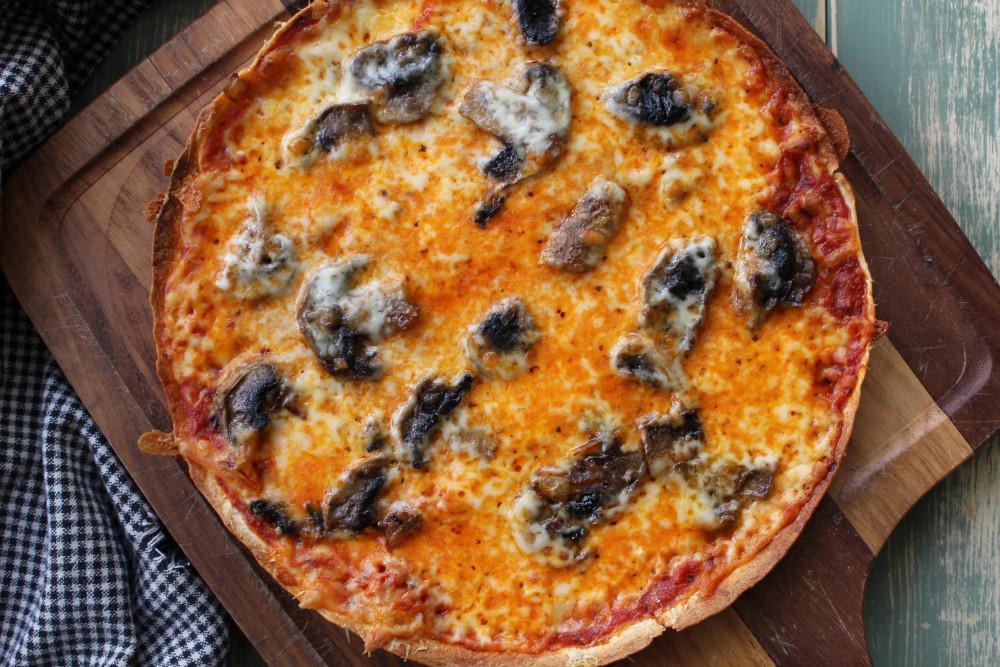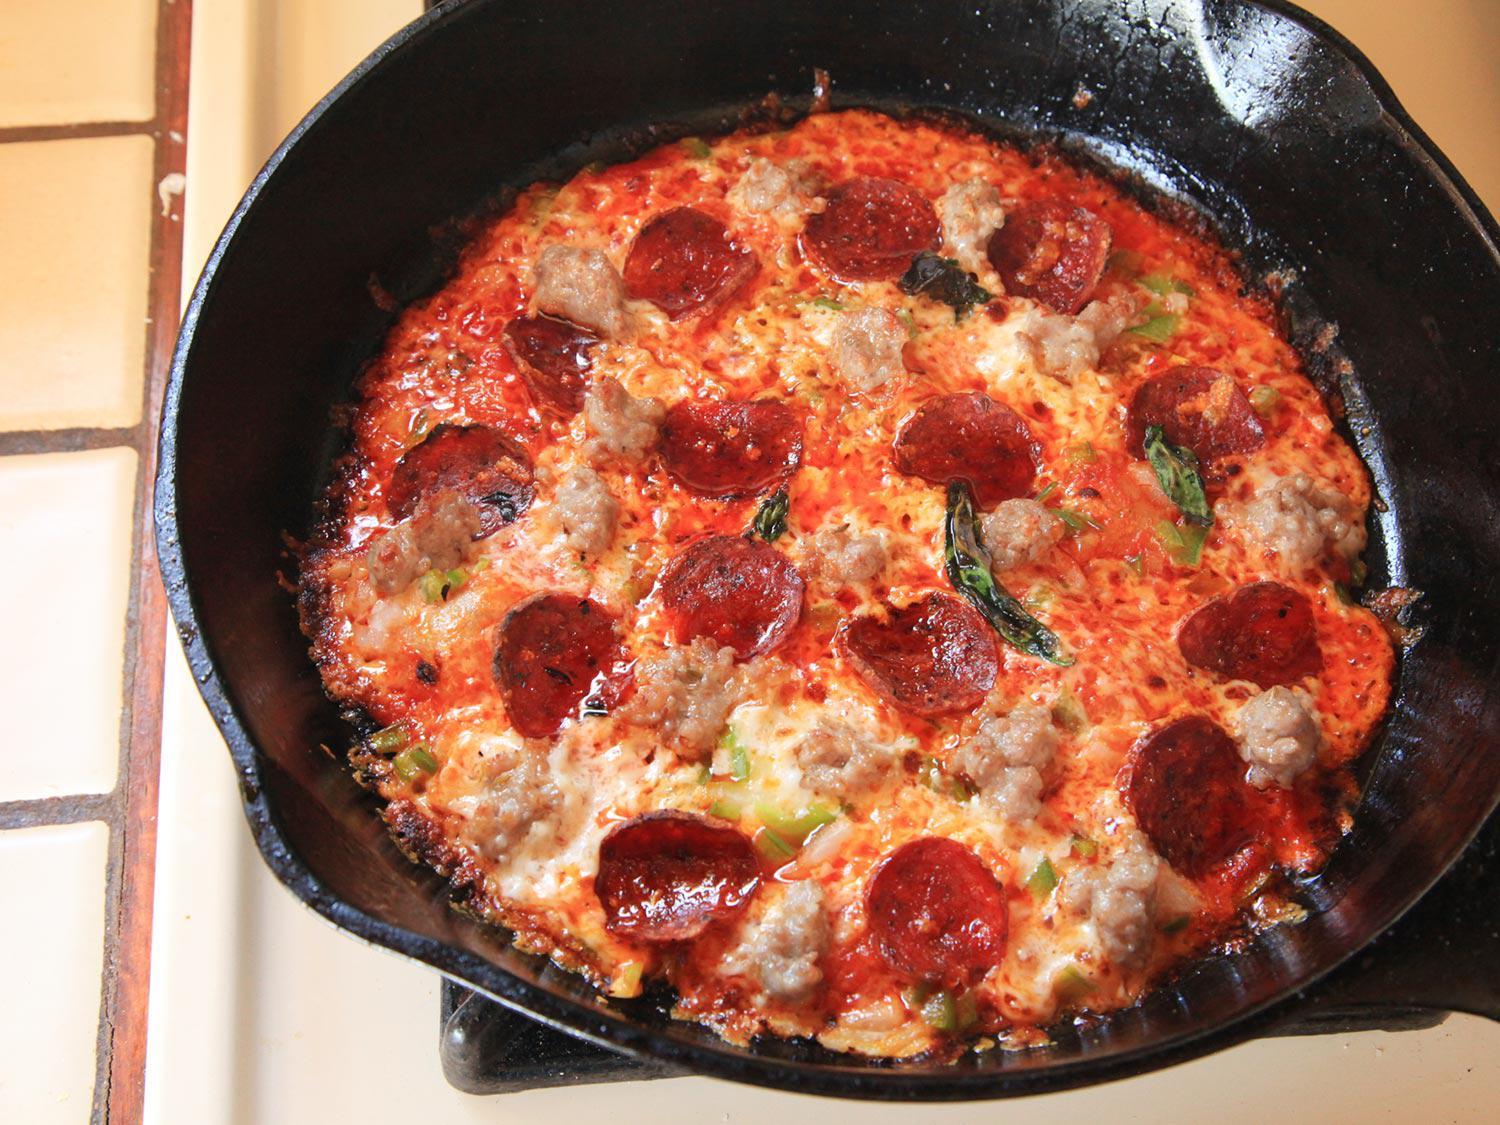The first image is the image on the left, the second image is the image on the right. Assess this claim about the two images: "There is pepperoni on one pizza but not the other.". Correct or not? Answer yes or no. Yes. The first image is the image on the left, the second image is the image on the right. Given the left and right images, does the statement "Each of the pizzas has been cut into individual pieces." hold true? Answer yes or no. No. 